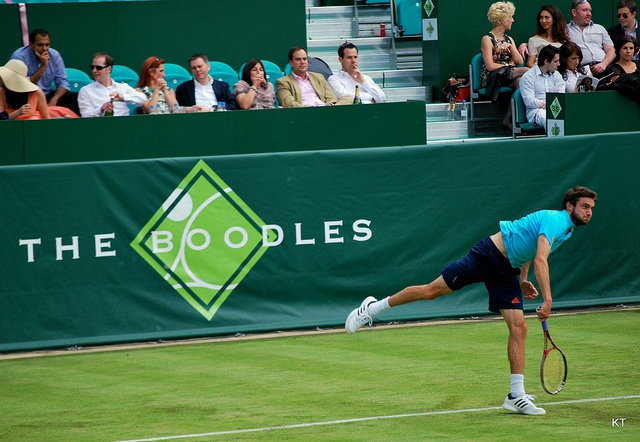Describe the objects in this image and their specific colors. I can see people in teal, black, brown, cyan, and maroon tones, people in teal, black, brown, gray, and tan tones, people in teal, lavender, brown, and darkgray tones, people in teal, black, gray, maroon, and navy tones, and people in teal, tan, and lavender tones in this image. 